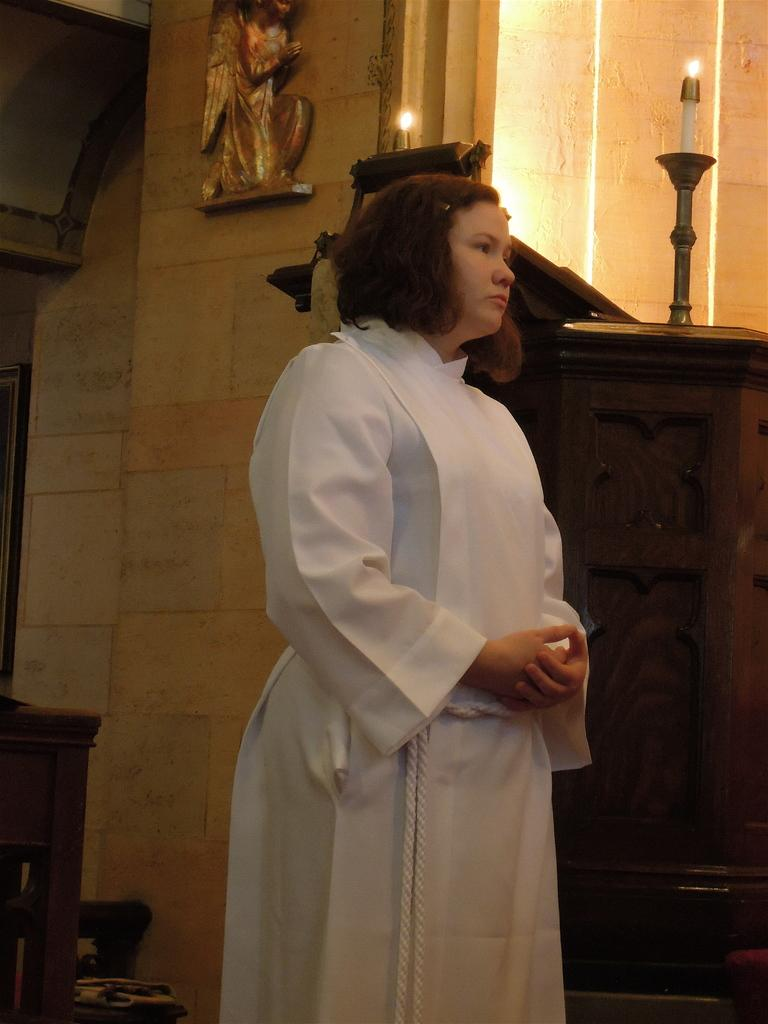What is the woman in the image wearing? The woman is wearing a white dress. What objects can be seen in the image besides the woman? There are candles, a table, and a photo frame on the wall in the image. What might the woman be standing near or on? The woman is likely standing near or on the table, as it is mentioned in the facts. What is the purpose of the photo frame in the image? The purpose of the photo frame is to display a photo or artwork on the wall. What type of celery is being used as a decoration on the table in the image? There is no celery present in the image; it only mentions candles and a photo frame on the wall. In which direction is the woman facing in the image? The direction the woman is facing cannot be determined from the provided facts. 